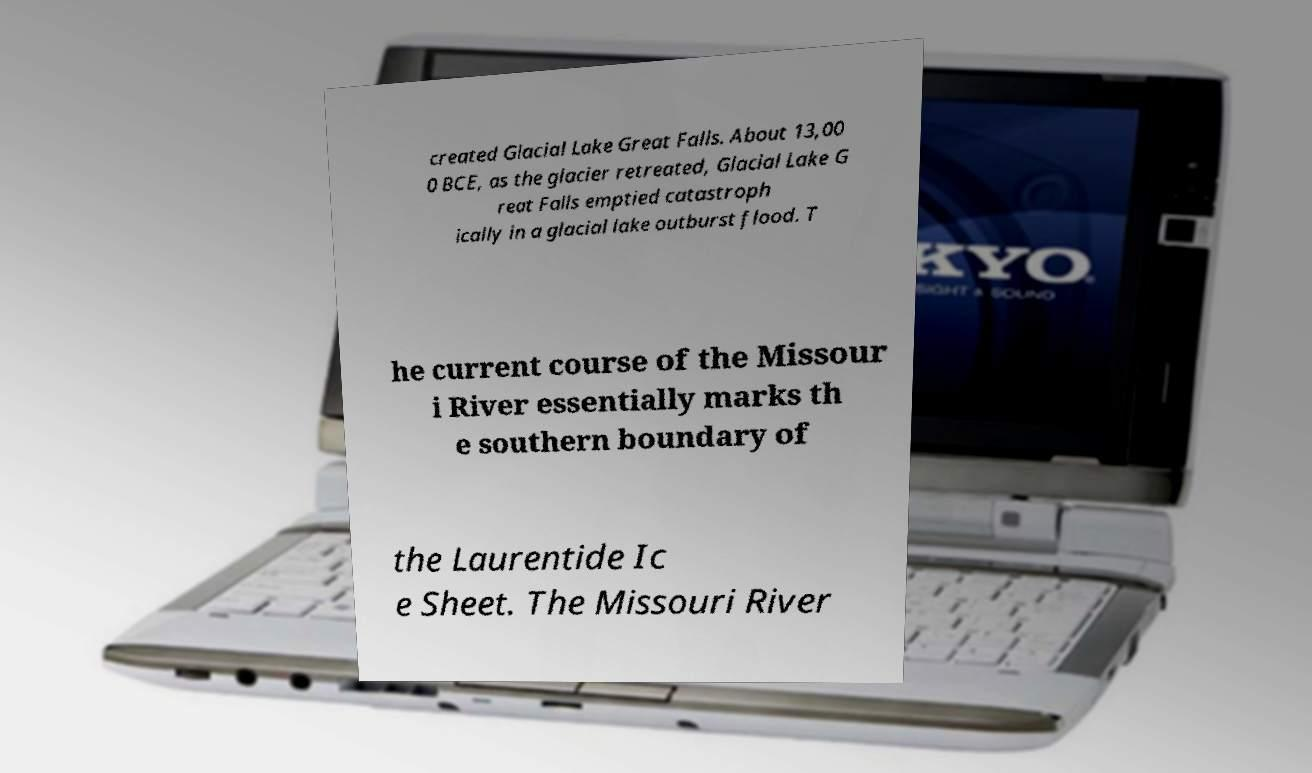There's text embedded in this image that I need extracted. Can you transcribe it verbatim? created Glacial Lake Great Falls. About 13,00 0 BCE, as the glacier retreated, Glacial Lake G reat Falls emptied catastroph ically in a glacial lake outburst flood. T he current course of the Missour i River essentially marks th e southern boundary of the Laurentide Ic e Sheet. The Missouri River 